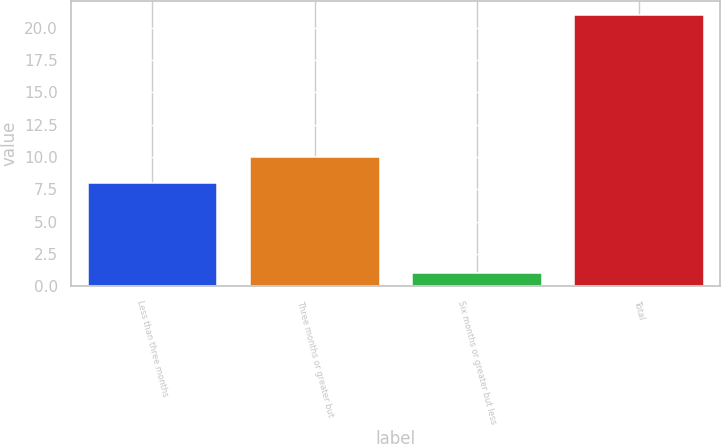Convert chart to OTSL. <chart><loc_0><loc_0><loc_500><loc_500><bar_chart><fcel>Less than three months<fcel>Three months or greater but<fcel>Six months or greater but less<fcel>Total<nl><fcel>8<fcel>10<fcel>1<fcel>21<nl></chart> 